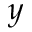<formula> <loc_0><loc_0><loc_500><loc_500>y</formula> 